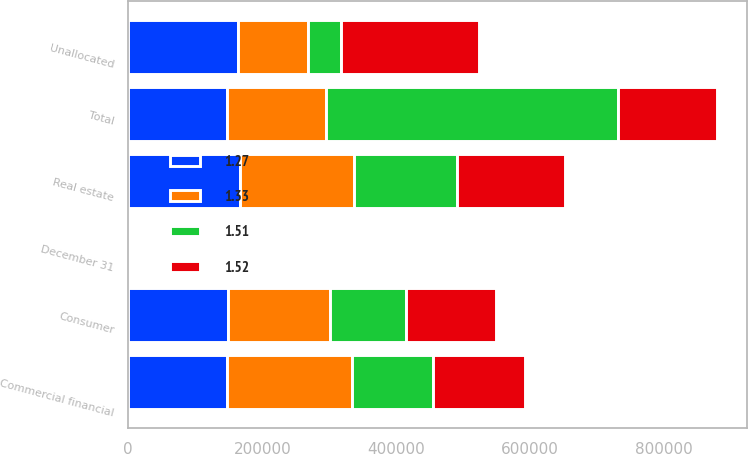Convert chart. <chart><loc_0><loc_0><loc_500><loc_500><stacked_bar_chart><ecel><fcel>December 31<fcel>Commercial financial<fcel>Real estate<fcel>Consumer<fcel>Unallocated<fcel>Total<nl><fcel>1.52<fcel>2005<fcel>136852<fcel>161003<fcel>133541<fcel>206267<fcel>147550<nl><fcel>1.27<fcel>2004<fcel>147550<fcel>166910<fcel>148591<fcel>163813<fcel>147550<nl><fcel>1.33<fcel>2003<fcel>186902<fcel>170493<fcel>152759<fcel>103904<fcel>147550<nl><fcel>1.51<fcel>2002<fcel>120627<fcel>152758<fcel>113711<fcel>49376<fcel>436472<nl></chart> 